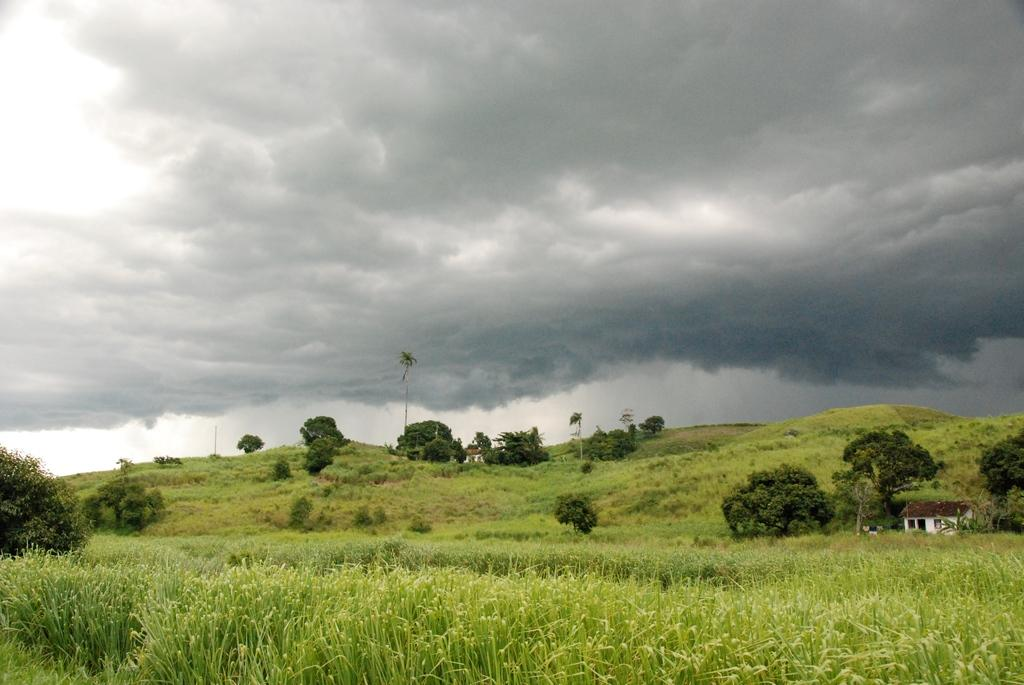What type of vegetation can be seen in the image? There are trees and grass in the image. What type of structures are visible in the image? There are houses in the image. What is visible in the background of the image? The sky is visible in the image. What can be seen in the sky? Clouds are present in the sky. What arithmetic problem is being solved on the tree in the image? There is no arithmetic problem present in the image; it features trees, grass, houses, and a sky with clouds. What type of sack is being used to transport the grass in the image? There is no sack or grass transportation activity depicted in the image. 